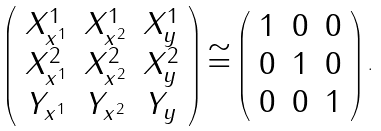<formula> <loc_0><loc_0><loc_500><loc_500>\left ( \begin{array} { c c c } X _ { x ^ { 1 } } ^ { 1 } & X _ { x ^ { 2 } } ^ { 1 } & X _ { y } ^ { 1 } \\ X _ { x ^ { 1 } } ^ { 2 } & X _ { x ^ { 2 } } ^ { 2 } & X _ { y } ^ { 2 } \\ Y _ { x ^ { 1 } } & Y _ { x ^ { 2 } } & Y _ { y } \\ \end{array} \right ) \cong \left ( \begin{array} { c c c } 1 & 0 & 0 \\ 0 & 1 & 0 \\ 0 & 0 & 1 \\ \end{array} \right ) .</formula> 